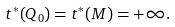Convert formula to latex. <formula><loc_0><loc_0><loc_500><loc_500>& t ^ { * } ( Q _ { 0 } ) = t ^ { * } ( M ) = + \infty .</formula> 